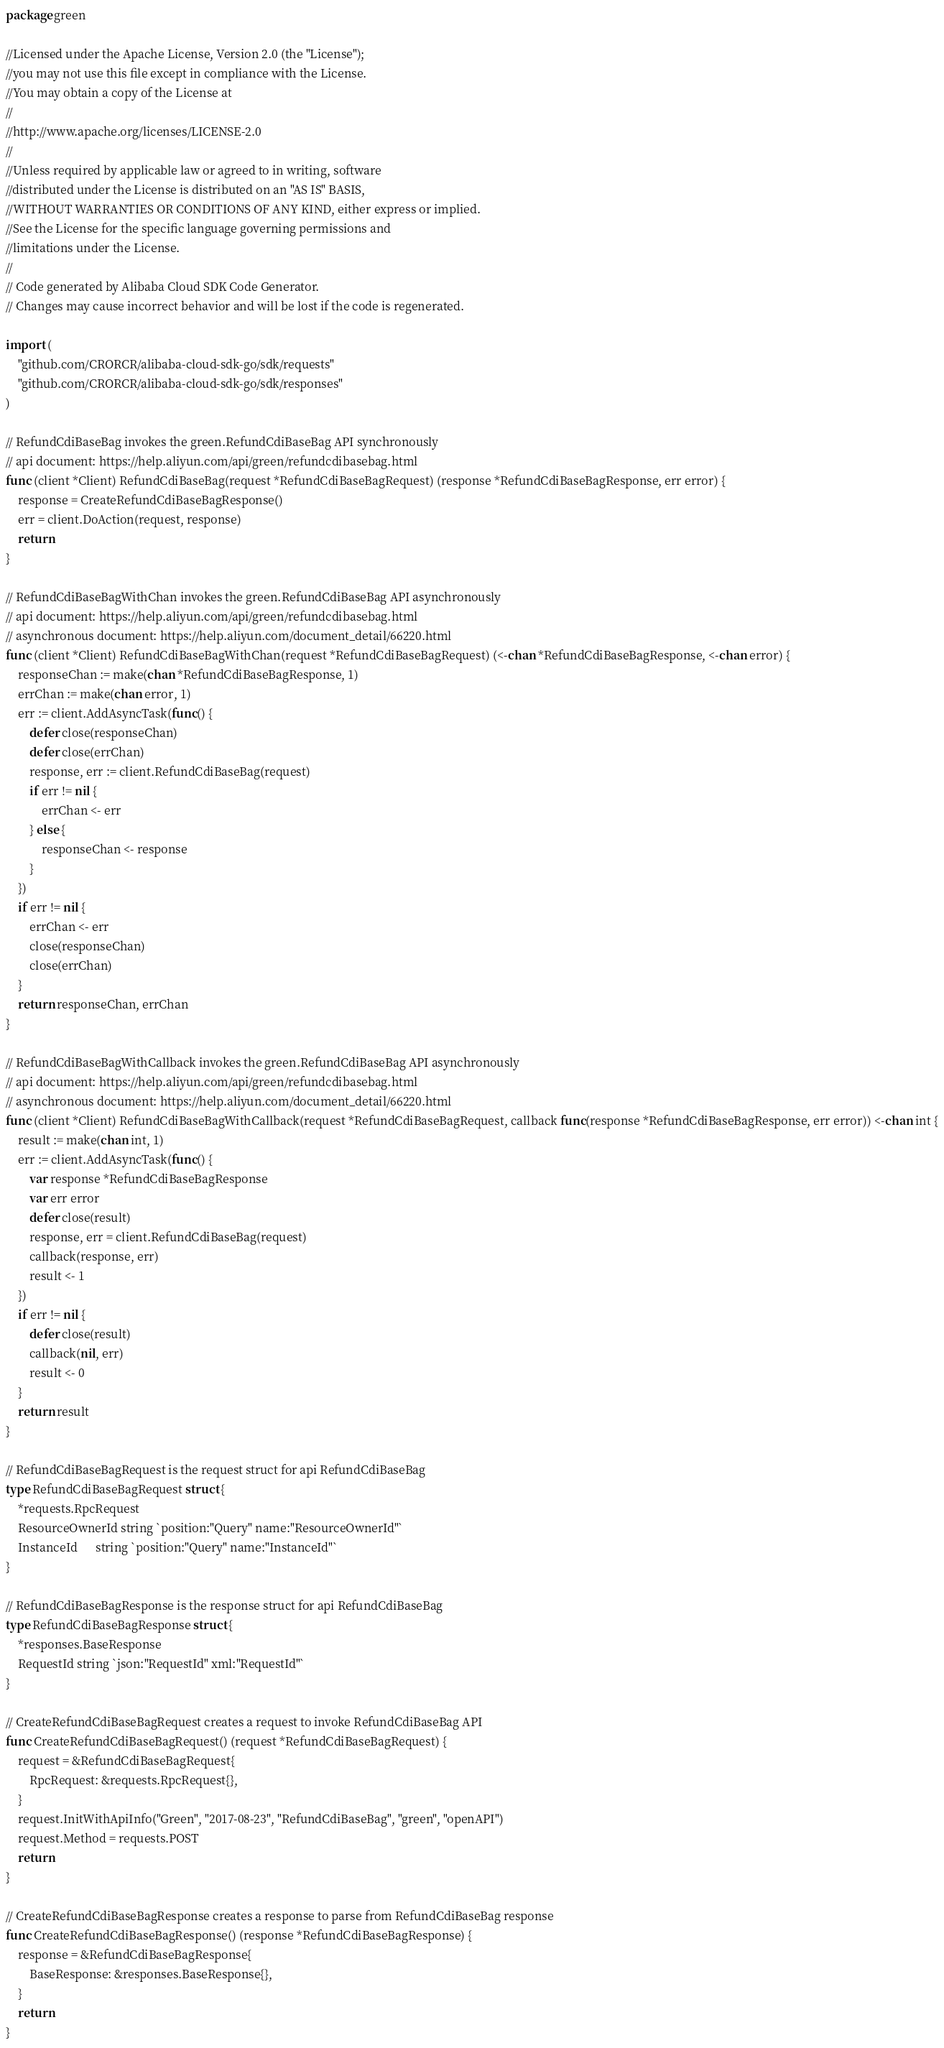<code> <loc_0><loc_0><loc_500><loc_500><_Go_>package green

//Licensed under the Apache License, Version 2.0 (the "License");
//you may not use this file except in compliance with the License.
//You may obtain a copy of the License at
//
//http://www.apache.org/licenses/LICENSE-2.0
//
//Unless required by applicable law or agreed to in writing, software
//distributed under the License is distributed on an "AS IS" BASIS,
//WITHOUT WARRANTIES OR CONDITIONS OF ANY KIND, either express or implied.
//See the License for the specific language governing permissions and
//limitations under the License.
//
// Code generated by Alibaba Cloud SDK Code Generator.
// Changes may cause incorrect behavior and will be lost if the code is regenerated.

import (
	"github.com/CRORCR/alibaba-cloud-sdk-go/sdk/requests"
	"github.com/CRORCR/alibaba-cloud-sdk-go/sdk/responses"
)

// RefundCdiBaseBag invokes the green.RefundCdiBaseBag API synchronously
// api document: https://help.aliyun.com/api/green/refundcdibasebag.html
func (client *Client) RefundCdiBaseBag(request *RefundCdiBaseBagRequest) (response *RefundCdiBaseBagResponse, err error) {
	response = CreateRefundCdiBaseBagResponse()
	err = client.DoAction(request, response)
	return
}

// RefundCdiBaseBagWithChan invokes the green.RefundCdiBaseBag API asynchronously
// api document: https://help.aliyun.com/api/green/refundcdibasebag.html
// asynchronous document: https://help.aliyun.com/document_detail/66220.html
func (client *Client) RefundCdiBaseBagWithChan(request *RefundCdiBaseBagRequest) (<-chan *RefundCdiBaseBagResponse, <-chan error) {
	responseChan := make(chan *RefundCdiBaseBagResponse, 1)
	errChan := make(chan error, 1)
	err := client.AddAsyncTask(func() {
		defer close(responseChan)
		defer close(errChan)
		response, err := client.RefundCdiBaseBag(request)
		if err != nil {
			errChan <- err
		} else {
			responseChan <- response
		}
	})
	if err != nil {
		errChan <- err
		close(responseChan)
		close(errChan)
	}
	return responseChan, errChan
}

// RefundCdiBaseBagWithCallback invokes the green.RefundCdiBaseBag API asynchronously
// api document: https://help.aliyun.com/api/green/refundcdibasebag.html
// asynchronous document: https://help.aliyun.com/document_detail/66220.html
func (client *Client) RefundCdiBaseBagWithCallback(request *RefundCdiBaseBagRequest, callback func(response *RefundCdiBaseBagResponse, err error)) <-chan int {
	result := make(chan int, 1)
	err := client.AddAsyncTask(func() {
		var response *RefundCdiBaseBagResponse
		var err error
		defer close(result)
		response, err = client.RefundCdiBaseBag(request)
		callback(response, err)
		result <- 1
	})
	if err != nil {
		defer close(result)
		callback(nil, err)
		result <- 0
	}
	return result
}

// RefundCdiBaseBagRequest is the request struct for api RefundCdiBaseBag
type RefundCdiBaseBagRequest struct {
	*requests.RpcRequest
	ResourceOwnerId string `position:"Query" name:"ResourceOwnerId"`
	InstanceId      string `position:"Query" name:"InstanceId"`
}

// RefundCdiBaseBagResponse is the response struct for api RefundCdiBaseBag
type RefundCdiBaseBagResponse struct {
	*responses.BaseResponse
	RequestId string `json:"RequestId" xml:"RequestId"`
}

// CreateRefundCdiBaseBagRequest creates a request to invoke RefundCdiBaseBag API
func CreateRefundCdiBaseBagRequest() (request *RefundCdiBaseBagRequest) {
	request = &RefundCdiBaseBagRequest{
		RpcRequest: &requests.RpcRequest{},
	}
	request.InitWithApiInfo("Green", "2017-08-23", "RefundCdiBaseBag", "green", "openAPI")
	request.Method = requests.POST
	return
}

// CreateRefundCdiBaseBagResponse creates a response to parse from RefundCdiBaseBag response
func CreateRefundCdiBaseBagResponse() (response *RefundCdiBaseBagResponse) {
	response = &RefundCdiBaseBagResponse{
		BaseResponse: &responses.BaseResponse{},
	}
	return
}
</code> 